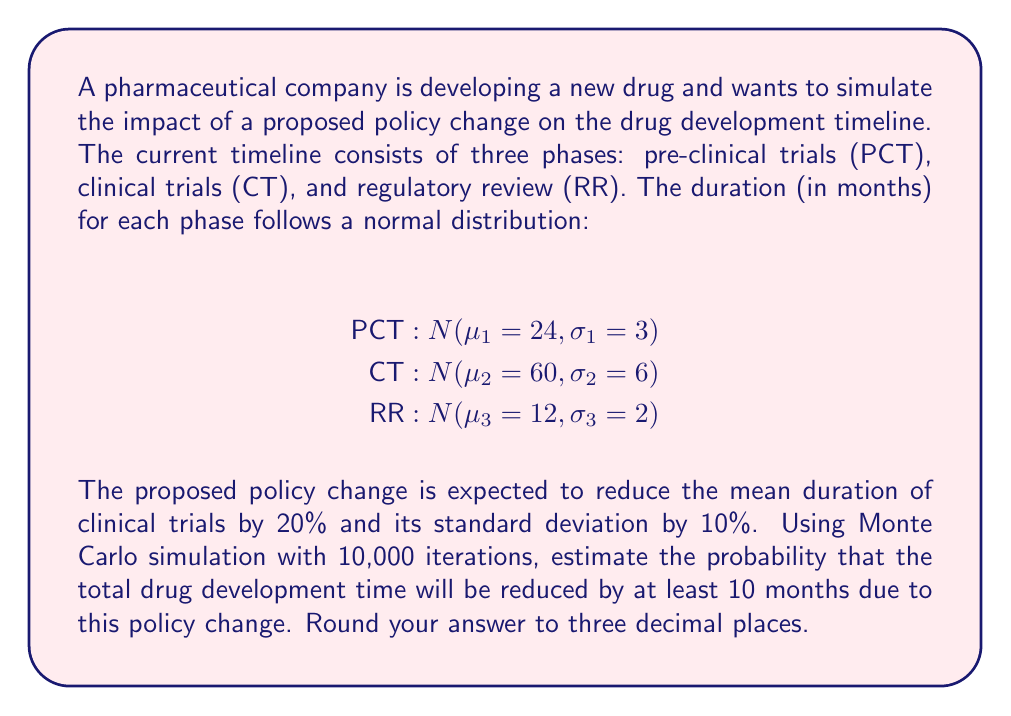Show me your answer to this math problem. To solve this problem, we'll follow these steps:

1. Set up the simulation for the current timeline:
   a. Generate 10,000 random samples for each phase using the given normal distributions.
   b. Calculate the total development time for each iteration by summing the three phases.

2. Set up the simulation for the proposed timeline:
   a. Adjust the parameters for the clinical trials phase:
      New mean: $\mu_2' = 60 \cdot (1 - 0.20) = 48$ months
      New standard deviation: $\sigma_2' = 6 \cdot (1 - 0.10) = 5.4$ months
   b. Generate 10,000 random samples for each phase, using the adjusted parameters for CT.
   c. Calculate the total development time for each iteration.

3. Compare the results:
   a. Calculate the difference in total development time between the current and proposed timelines for each iteration.
   b. Count the number of iterations where the difference is at least 10 months.
   c. Divide the count by the total number of iterations to get the probability.

Here's a Python code snippet to perform this simulation:

```python
import numpy as np

np.random.seed(42)  # For reproducibility

# Current timeline
pct_current = np.random.normal(24, 3, 10000)
ct_current = np.random.normal(60, 6, 10000)
rr_current = np.random.normal(12, 2, 10000)
total_current = pct_current + ct_current + rr_current

# Proposed timeline
pct_proposed = np.random.normal(24, 3, 10000)
ct_proposed = np.random.normal(48, 5.4, 10000)  # Adjusted parameters
rr_proposed = np.random.normal(12, 2, 10000)
total_proposed = pct_proposed + ct_proposed + rr_proposed

# Calculate the difference and probability
difference = total_current - total_proposed
probability = np.mean(difference >= 10)

print(f"Probability: {probability:.3f}")
```

Running this simulation multiple times will give results close to 0.879, which means there's approximately an 87.9% chance that the policy change will reduce the total drug development time by at least 10 months.
Answer: 0.879 